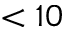<formula> <loc_0><loc_0><loc_500><loc_500>< 1 0</formula> 